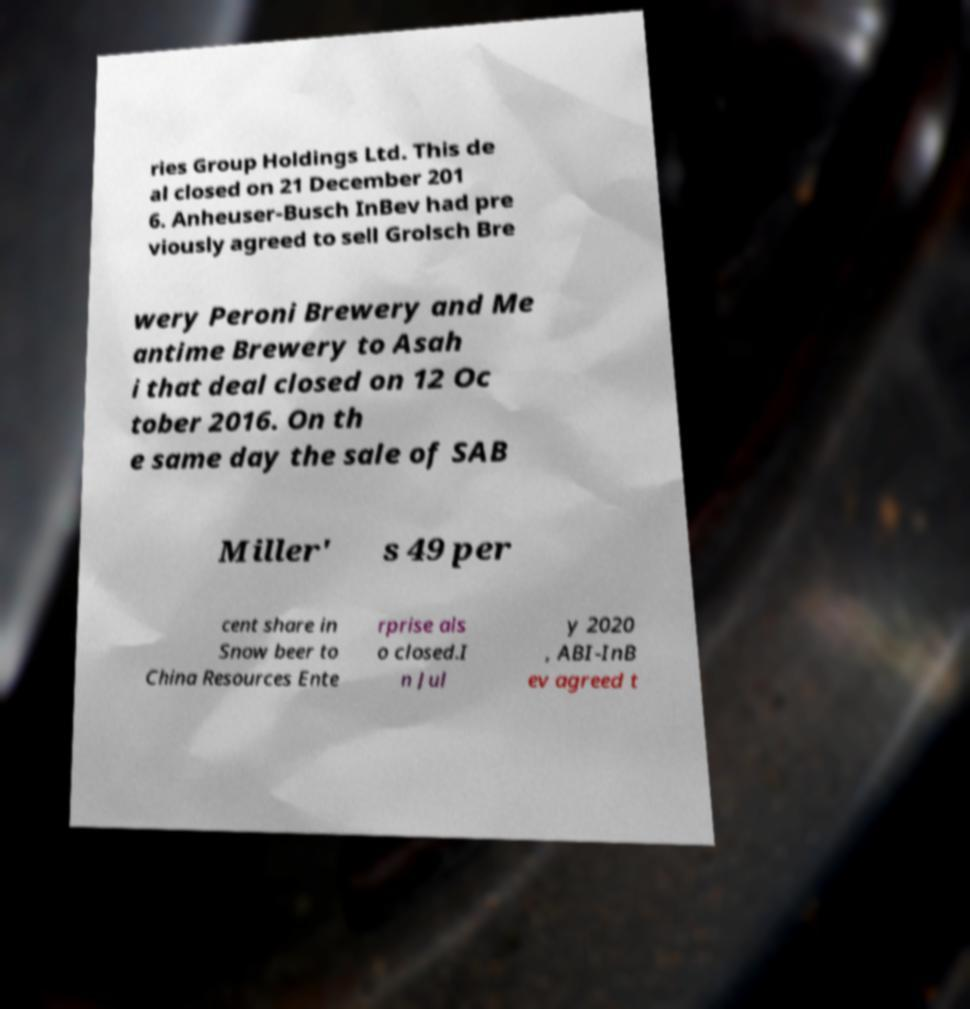There's text embedded in this image that I need extracted. Can you transcribe it verbatim? ries Group Holdings Ltd. This de al closed on 21 December 201 6. Anheuser-Busch InBev had pre viously agreed to sell Grolsch Bre wery Peroni Brewery and Me antime Brewery to Asah i that deal closed on 12 Oc tober 2016. On th e same day the sale of SAB Miller' s 49 per cent share in Snow beer to China Resources Ente rprise als o closed.I n Jul y 2020 , ABI-InB ev agreed t 